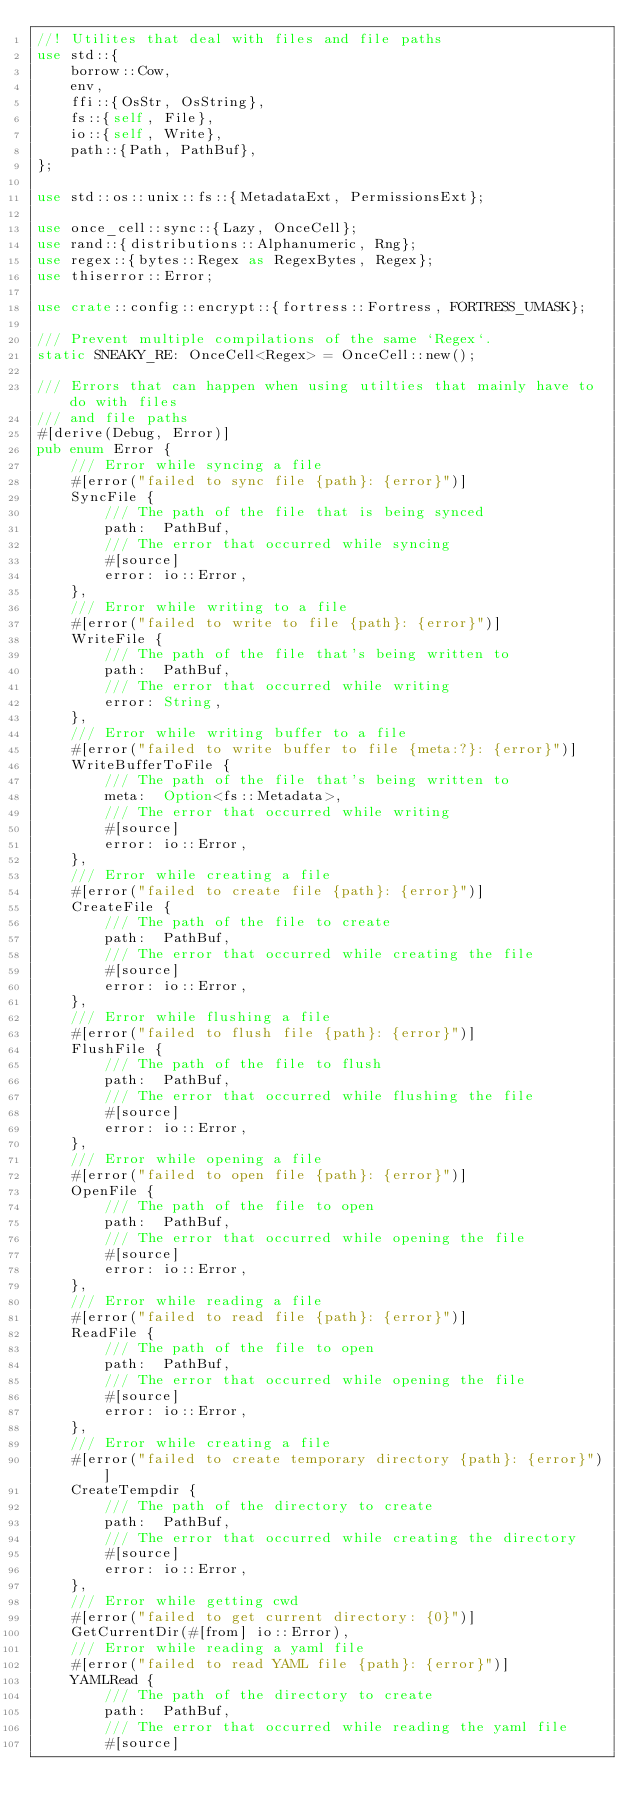<code> <loc_0><loc_0><loc_500><loc_500><_Rust_>//! Utilites that deal with files and file paths
use std::{
    borrow::Cow,
    env,
    ffi::{OsStr, OsString},
    fs::{self, File},
    io::{self, Write},
    path::{Path, PathBuf},
};

use std::os::unix::fs::{MetadataExt, PermissionsExt};

use once_cell::sync::{Lazy, OnceCell};
use rand::{distributions::Alphanumeric, Rng};
use regex::{bytes::Regex as RegexBytes, Regex};
use thiserror::Error;

use crate::config::encrypt::{fortress::Fortress, FORTRESS_UMASK};

/// Prevent multiple compilations of the same `Regex`.
static SNEAKY_RE: OnceCell<Regex> = OnceCell::new();

/// Errors that can happen when using utilties that mainly have to do with files
/// and file paths
#[derive(Debug, Error)]
pub enum Error {
    /// Error while syncing a file
    #[error("failed to sync file {path}: {error}")]
    SyncFile {
        /// The path of the file that is being synced
        path:  PathBuf,
        /// The error that occurred while syncing
        #[source]
        error: io::Error,
    },
    /// Error while writing to a file
    #[error("failed to write to file {path}: {error}")]
    WriteFile {
        /// The path of the file that's being written to
        path:  PathBuf,
        /// The error that occurred while writing
        error: String,
    },
    /// Error while writing buffer to a file
    #[error("failed to write buffer to file {meta:?}: {error}")]
    WriteBufferToFile {
        /// The path of the file that's being written to
        meta:  Option<fs::Metadata>,
        /// The error that occurred while writing
        #[source]
        error: io::Error,
    },
    /// Error while creating a file
    #[error("failed to create file {path}: {error}")]
    CreateFile {
        /// The path of the file to create
        path:  PathBuf,
        /// The error that occurred while creating the file
        #[source]
        error: io::Error,
    },
    /// Error while flushing a file
    #[error("failed to flush file {path}: {error}")]
    FlushFile {
        /// The path of the file to flush
        path:  PathBuf,
        /// The error that occurred while flushing the file
        #[source]
        error: io::Error,
    },
    /// Error while opening a file
    #[error("failed to open file {path}: {error}")]
    OpenFile {
        /// The path of the file to open
        path:  PathBuf,
        /// The error that occurred while opening the file
        #[source]
        error: io::Error,
    },
    /// Error while reading a file
    #[error("failed to read file {path}: {error}")]
    ReadFile {
        /// The path of the file to open
        path:  PathBuf,
        /// The error that occurred while opening the file
        #[source]
        error: io::Error,
    },
    /// Error while creating a file
    #[error("failed to create temporary directory {path}: {error}")]
    CreateTempdir {
        /// The path of the directory to create
        path:  PathBuf,
        /// The error that occurred while creating the directory
        #[source]
        error: io::Error,
    },
    /// Error while getting cwd
    #[error("failed to get current directory: {0}")]
    GetCurrentDir(#[from] io::Error),
    /// Error while reading a yaml file
    #[error("failed to read YAML file {path}: {error}")]
    YAMLRead {
        /// The path of the directory to create
        path:  PathBuf,
        /// The error that occurred while reading the yaml file
        #[source]</code> 